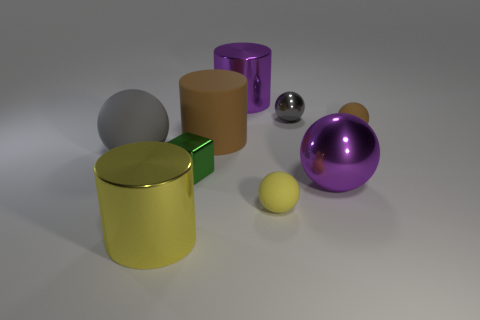Is the color of the ball that is left of the tiny yellow ball the same as the small metallic sphere?
Keep it short and to the point. Yes. What is the color of the large thing that is on the left side of the gray shiny object and in front of the big gray sphere?
Your response must be concise. Yellow. Is there a gray object that has the same material as the green block?
Provide a short and direct response. Yes. The brown rubber cylinder is what size?
Your answer should be compact. Large. There is a shiny cylinder to the right of the big metal cylinder that is to the left of the small green metal block; what is its size?
Give a very brief answer. Large. There is a purple object that is the same shape as the small gray shiny object; what is its material?
Offer a terse response. Metal. What number of large gray shiny cylinders are there?
Provide a succinct answer. 0. What is the color of the big object right of the metal cylinder behind the cylinder to the left of the brown cylinder?
Your answer should be compact. Purple. Is the number of big shiny spheres less than the number of matte things?
Keep it short and to the point. Yes. There is another large metallic thing that is the same shape as the gray shiny object; what is its color?
Provide a short and direct response. Purple. 